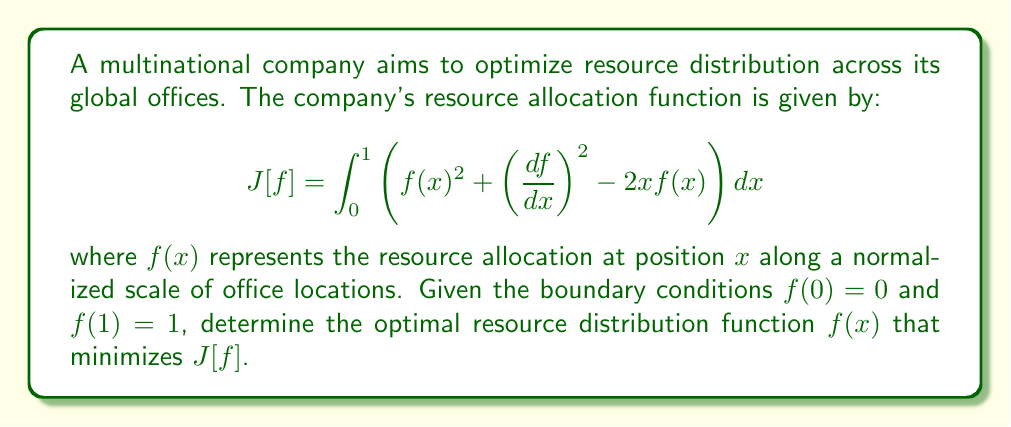Give your solution to this math problem. To solve this problem using variational calculus, we follow these steps:

1) The Euler-Lagrange equation for this functional is:

   $$\frac{\partial L}{\partial f} - \frac{d}{dx}\left(\frac{\partial L}{\partial f'}\right) = 0$$

   where $L = f(x)^2 + \left(\frac{df}{dx}\right)^2 - 2xf(x)$

2) Calculating the partial derivatives:

   $$\frac{\partial L}{\partial f} = 2f(x) - 2x$$
   $$\frac{\partial L}{\partial f'} = 2f'(x)$$

3) Substituting into the Euler-Lagrange equation:

   $$2f(x) - 2x - \frac{d}{dx}(2f'(x)) = 0$$
   $$2f(x) - 2x - 2f''(x) = 0$$

4) Rearranging:

   $$f''(x) - f(x) = -x$$

5) This is a non-homogeneous second-order differential equation. The general solution is:

   $$f(x) = A\sinh(x) + B\cosh(x) + x$$

   where $A$ and $B$ are constants to be determined from the boundary conditions.

6) Applying the boundary conditions:

   At $x = 0$: $f(0) = 0 = B + 0$, so $B = 0$
   At $x = 1$: $f(1) = 1 = A\sinh(1) + \cosh(1) + 1$

7) Solving for $A$:

   $$A = \frac{1 - \cosh(1) - 1}{\sinh(1)} = \frac{-\cosh(1)}{\sinh(1)} = -\coth(1)$$

8) Therefore, the optimal resource distribution function is:

   $$f(x) = -\coth(1)\sinh(x) + x$$

This function minimizes the given functional $J[f]$ subject to the specified boundary conditions.
Answer: $f(x) = -\coth(1)\sinh(x) + x$ 